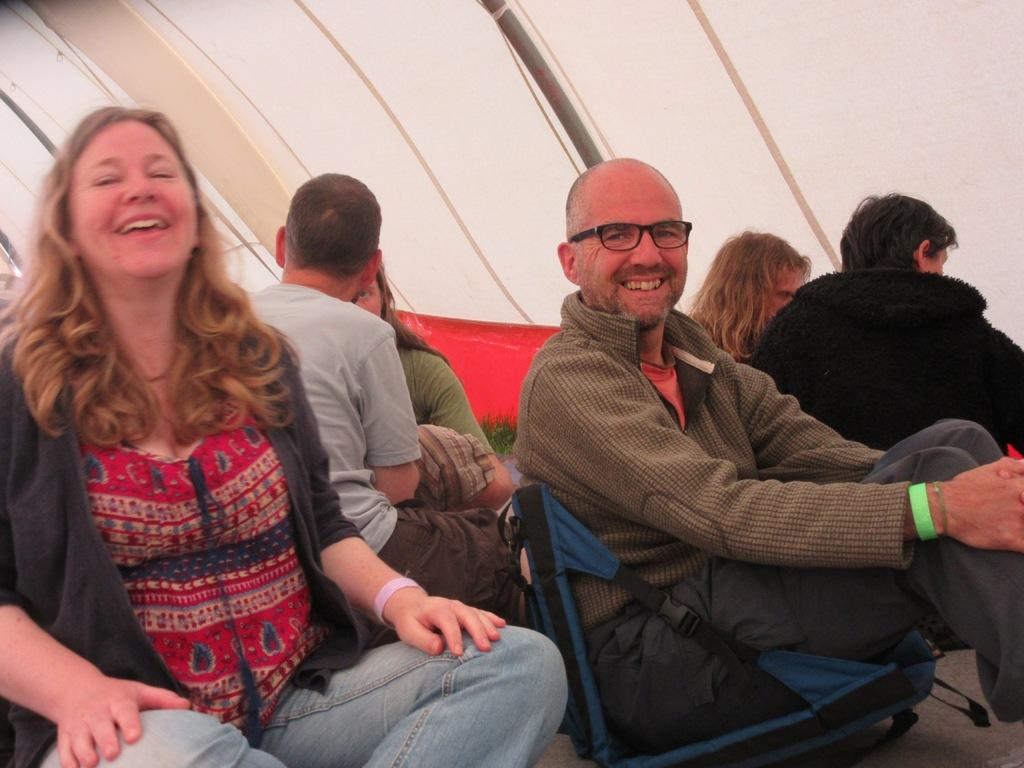What is the main subject of the image? The main subject of the image is a woman. What is the woman wearing? The woman is wearing jeans. What is the woman's facial expression? The woman is smiling. How is the woman positioned in relation to another person? The woman is sitting near a person. What is the person sitting on? The person is sitting on a chair. Can you describe the background of the image? There are other persons sitting in the background, and there is a white wall in the background. What type of curtain can be seen hanging from the ceiling in the image? There is no curtain present in the image. What is the reason for the woman's smile in the image? The image does not provide any information about the reason for the woman's smile. 